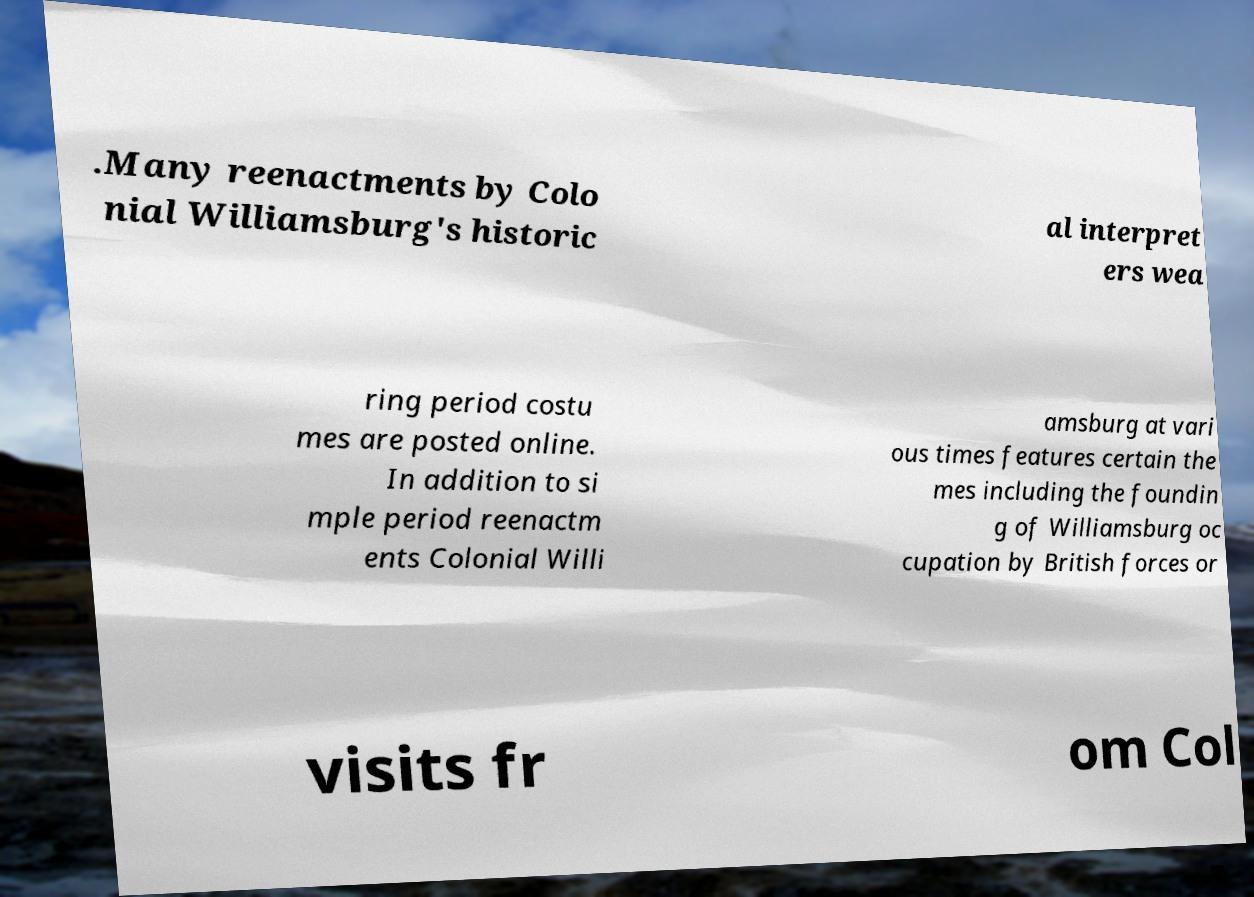There's text embedded in this image that I need extracted. Can you transcribe it verbatim? .Many reenactments by Colo nial Williamsburg's historic al interpret ers wea ring period costu mes are posted online. In addition to si mple period reenactm ents Colonial Willi amsburg at vari ous times features certain the mes including the foundin g of Williamsburg oc cupation by British forces or visits fr om Col 